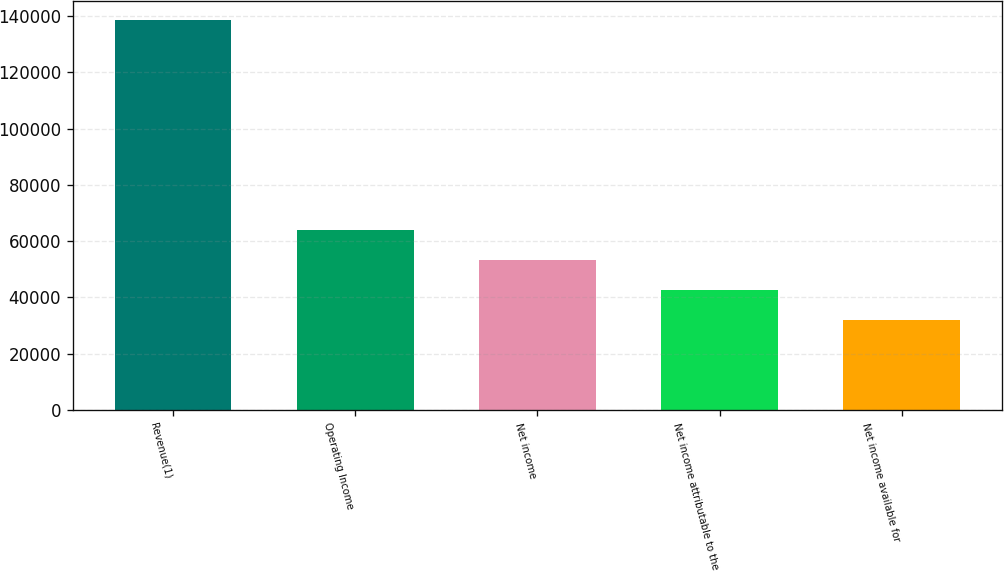Convert chart to OTSL. <chart><loc_0><loc_0><loc_500><loc_500><bar_chart><fcel>Revenue(1)<fcel>Operating Income<fcel>Net income<fcel>Net income attributable to the<fcel>Net income available for<nl><fcel>138613<fcel>63868.4<fcel>53190.6<fcel>42512.8<fcel>31835<nl></chart> 